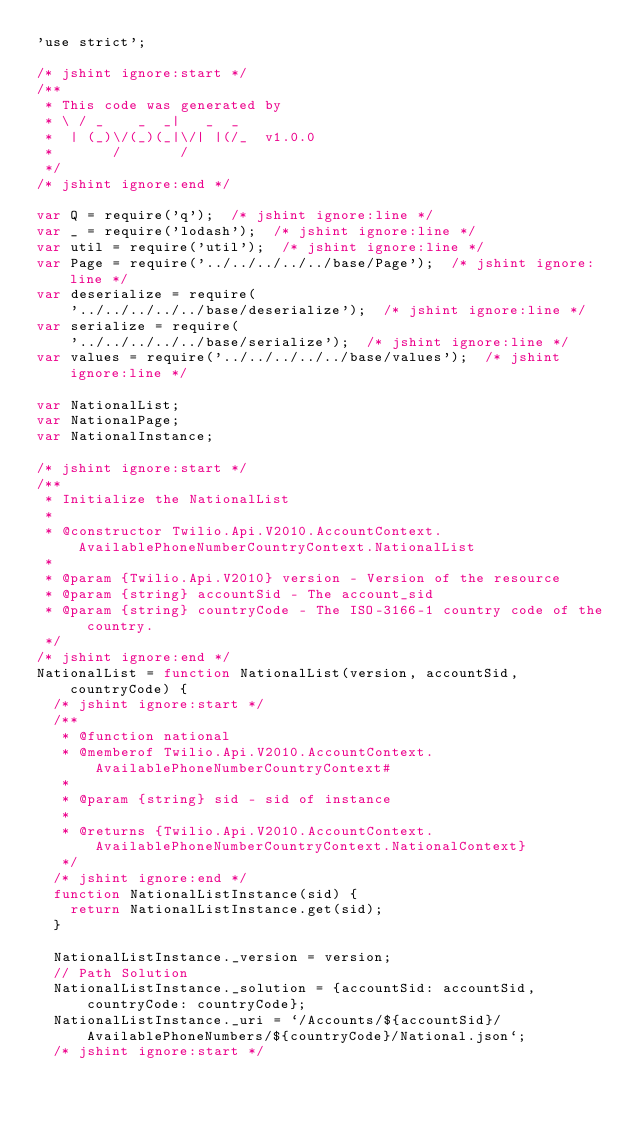Convert code to text. <code><loc_0><loc_0><loc_500><loc_500><_JavaScript_>'use strict';

/* jshint ignore:start */
/**
 * This code was generated by
 * \ / _    _  _|   _  _
 *  | (_)\/(_)(_|\/| |(/_  v1.0.0
 *       /       /
 */
/* jshint ignore:end */

var Q = require('q');  /* jshint ignore:line */
var _ = require('lodash');  /* jshint ignore:line */
var util = require('util');  /* jshint ignore:line */
var Page = require('../../../../../base/Page');  /* jshint ignore:line */
var deserialize = require(
    '../../../../../base/deserialize');  /* jshint ignore:line */
var serialize = require(
    '../../../../../base/serialize');  /* jshint ignore:line */
var values = require('../../../../../base/values');  /* jshint ignore:line */

var NationalList;
var NationalPage;
var NationalInstance;

/* jshint ignore:start */
/**
 * Initialize the NationalList
 *
 * @constructor Twilio.Api.V2010.AccountContext.AvailablePhoneNumberCountryContext.NationalList
 *
 * @param {Twilio.Api.V2010} version - Version of the resource
 * @param {string} accountSid - The account_sid
 * @param {string} countryCode - The ISO-3166-1 country code of the country.
 */
/* jshint ignore:end */
NationalList = function NationalList(version, accountSid, countryCode) {
  /* jshint ignore:start */
  /**
   * @function national
   * @memberof Twilio.Api.V2010.AccountContext.AvailablePhoneNumberCountryContext#
   *
   * @param {string} sid - sid of instance
   *
   * @returns {Twilio.Api.V2010.AccountContext.AvailablePhoneNumberCountryContext.NationalContext}
   */
  /* jshint ignore:end */
  function NationalListInstance(sid) {
    return NationalListInstance.get(sid);
  }

  NationalListInstance._version = version;
  // Path Solution
  NationalListInstance._solution = {accountSid: accountSid, countryCode: countryCode};
  NationalListInstance._uri = `/Accounts/${accountSid}/AvailablePhoneNumbers/${countryCode}/National.json`;
  /* jshint ignore:start */</code> 